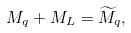Convert formula to latex. <formula><loc_0><loc_0><loc_500><loc_500>M _ { q } + M _ { L } = { \widetilde { M } } _ { q } ,</formula> 